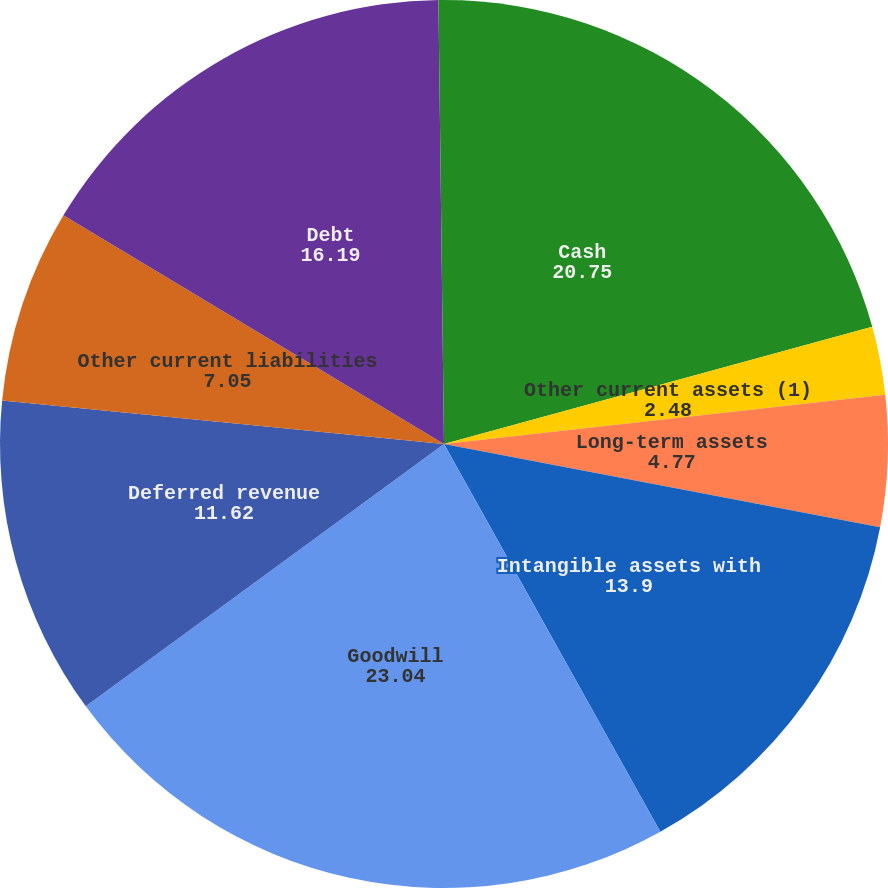Convert chart. <chart><loc_0><loc_0><loc_500><loc_500><pie_chart><fcel>Cash<fcel>Other current assets (1)<fcel>Long-term assets<fcel>Intangible assets with<fcel>Goodwill<fcel>Deferred revenue<fcel>Other current liabilities<fcel>Debt<fcel>Other long-term liabilities<nl><fcel>20.75%<fcel>2.48%<fcel>4.77%<fcel>13.9%<fcel>23.04%<fcel>11.62%<fcel>7.05%<fcel>16.19%<fcel>0.2%<nl></chart> 